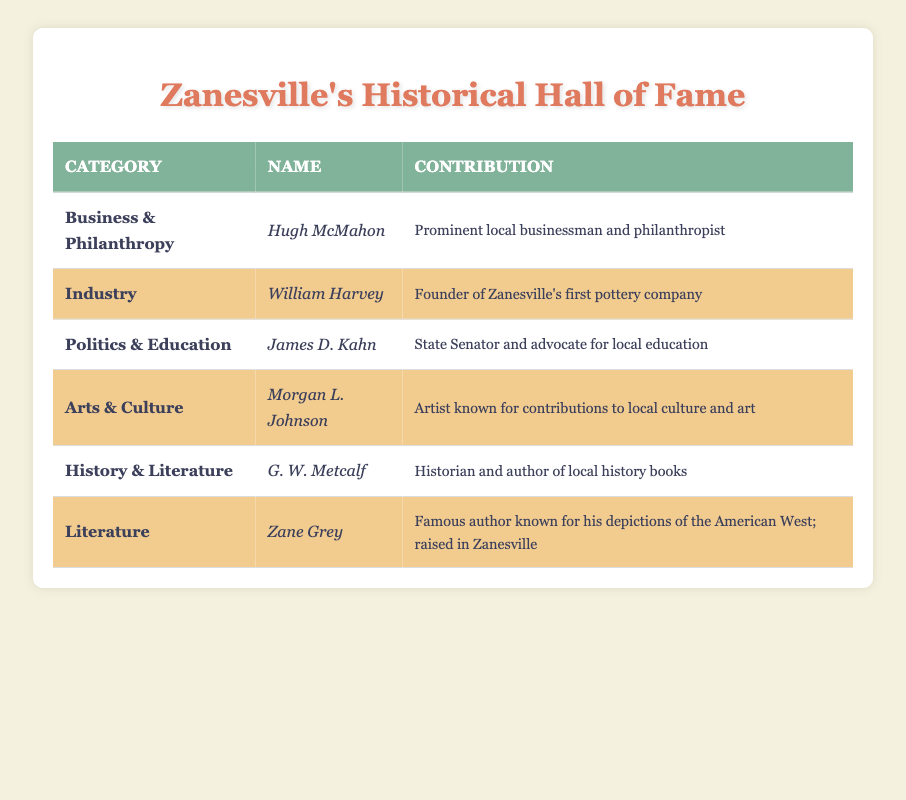What category does Zane Grey belong to? By looking at the table, the name 'Zane Grey' is found under the category 'Literature' in the respective row assigned to him.
Answer: Literature Who contributed to the local culture and art? The table shows that 'Morgan L. Johnson' is the individual known for contributions to local culture and art.
Answer: Morgan L. Johnson Is Hugh McMahon associated with politics? The table lists 'Hugh McMahon' under the category 'Business & Philanthropy', which does not include politics, thus he is not associated with it.
Answer: No How many individuals contributed to the category of 'History & Literature'? There is only one individual listed under 'History & Literature' in the table, which is 'G. W. Metcalf'.
Answer: 1 Which historical figure is noted as a state senator? According to the table, 'James D. Kahn' is recognized as a state senator, as indicated in his contribution field.
Answer: James D. Kahn What is the sum of the unique categories represented in the table? The unique categories listed in the table are 'Business & Philanthropy', 'Industry', 'Politics & Education', 'Arts & Culture', 'History & Literature', and 'Literature'. There are 6 unique categories in total.
Answer: 6 Was William Harvey involved in arts or culture? In reviewing the table, 'William Harvey' is categorized under 'Industry', which confirms he was not involved in arts or culture.
Answer: No How many figures listed in the table have contributions related to literature or history? The table includes two figures related to literature: 'Zane Grey' and 'G. W. Metcalf'. Thus, the count of individuals with contributions related to literature or history is 2.
Answer: 2 Which figure is known for being a philanthropist? 'Hugh McMahon' is recorded in the table with the contribution of being a prominent local businessman and philanthropist, making him the relevant figure for this question.
Answer: Hugh McMahon 